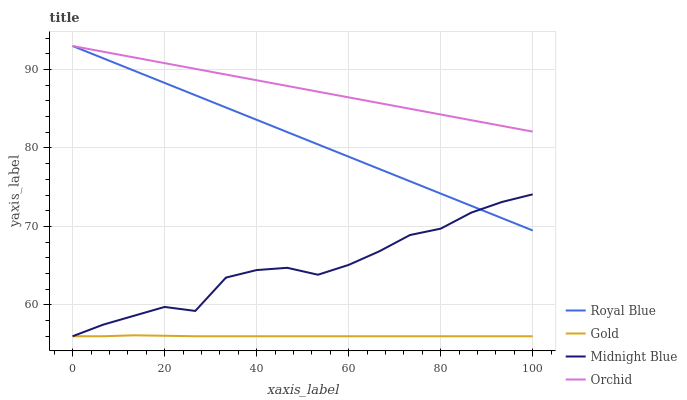Does Gold have the minimum area under the curve?
Answer yes or no. Yes. Does Orchid have the maximum area under the curve?
Answer yes or no. Yes. Does Midnight Blue have the minimum area under the curve?
Answer yes or no. No. Does Midnight Blue have the maximum area under the curve?
Answer yes or no. No. Is Orchid the smoothest?
Answer yes or no. Yes. Is Midnight Blue the roughest?
Answer yes or no. Yes. Is Gold the smoothest?
Answer yes or no. No. Is Gold the roughest?
Answer yes or no. No. Does Midnight Blue have the lowest value?
Answer yes or no. Yes. Does Orchid have the lowest value?
Answer yes or no. No. Does Orchid have the highest value?
Answer yes or no. Yes. Does Midnight Blue have the highest value?
Answer yes or no. No. Is Gold less than Royal Blue?
Answer yes or no. Yes. Is Orchid greater than Gold?
Answer yes or no. Yes. Does Royal Blue intersect Midnight Blue?
Answer yes or no. Yes. Is Royal Blue less than Midnight Blue?
Answer yes or no. No. Is Royal Blue greater than Midnight Blue?
Answer yes or no. No. Does Gold intersect Royal Blue?
Answer yes or no. No. 